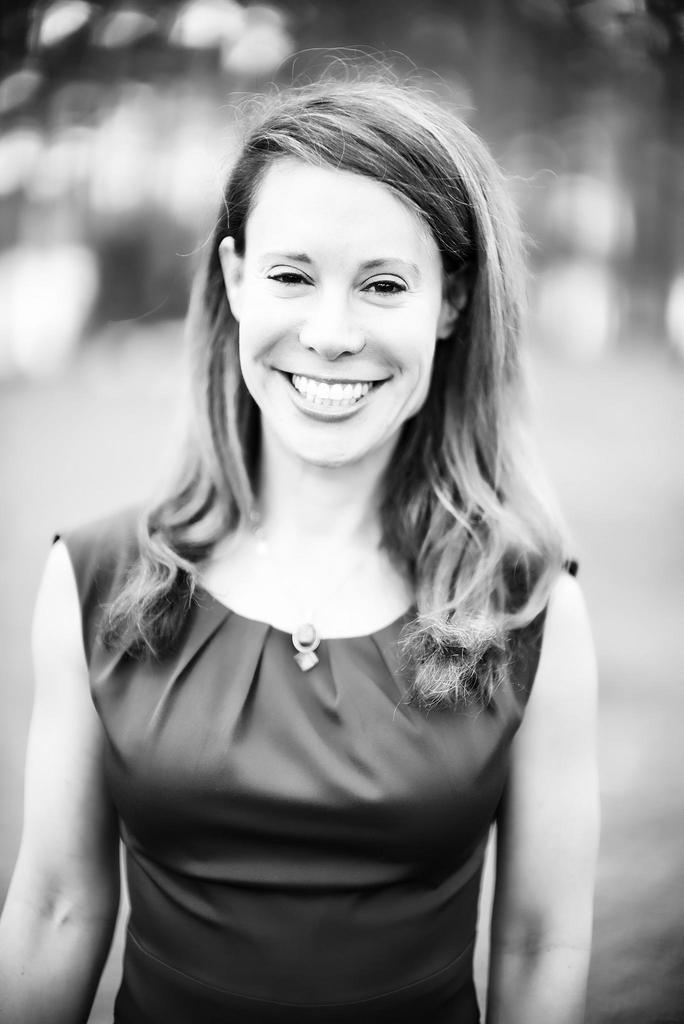What is the color scheme of the image? The image is black and white. Who is present in the image? There is a woman in the image. Where is the woman located in the image? The woman is standing in the middle of the image. What is the woman's expression in the image? The woman is smiling. What type of coast can be seen in the background of the image? There is no coast visible in the image, as it is a black and white image of a woman standing and smiling. 